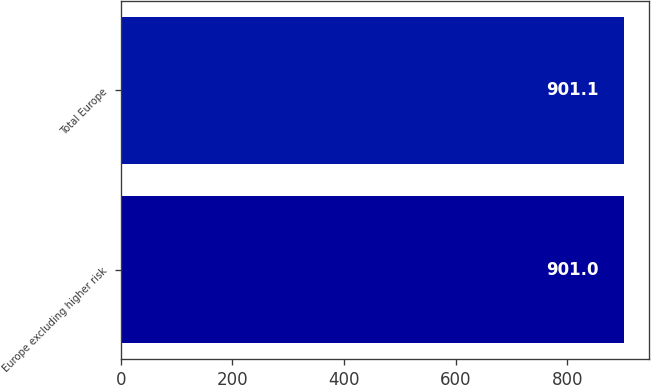Convert chart to OTSL. <chart><loc_0><loc_0><loc_500><loc_500><bar_chart><fcel>Europe excluding higher risk<fcel>Total Europe<nl><fcel>901<fcel>901.1<nl></chart> 